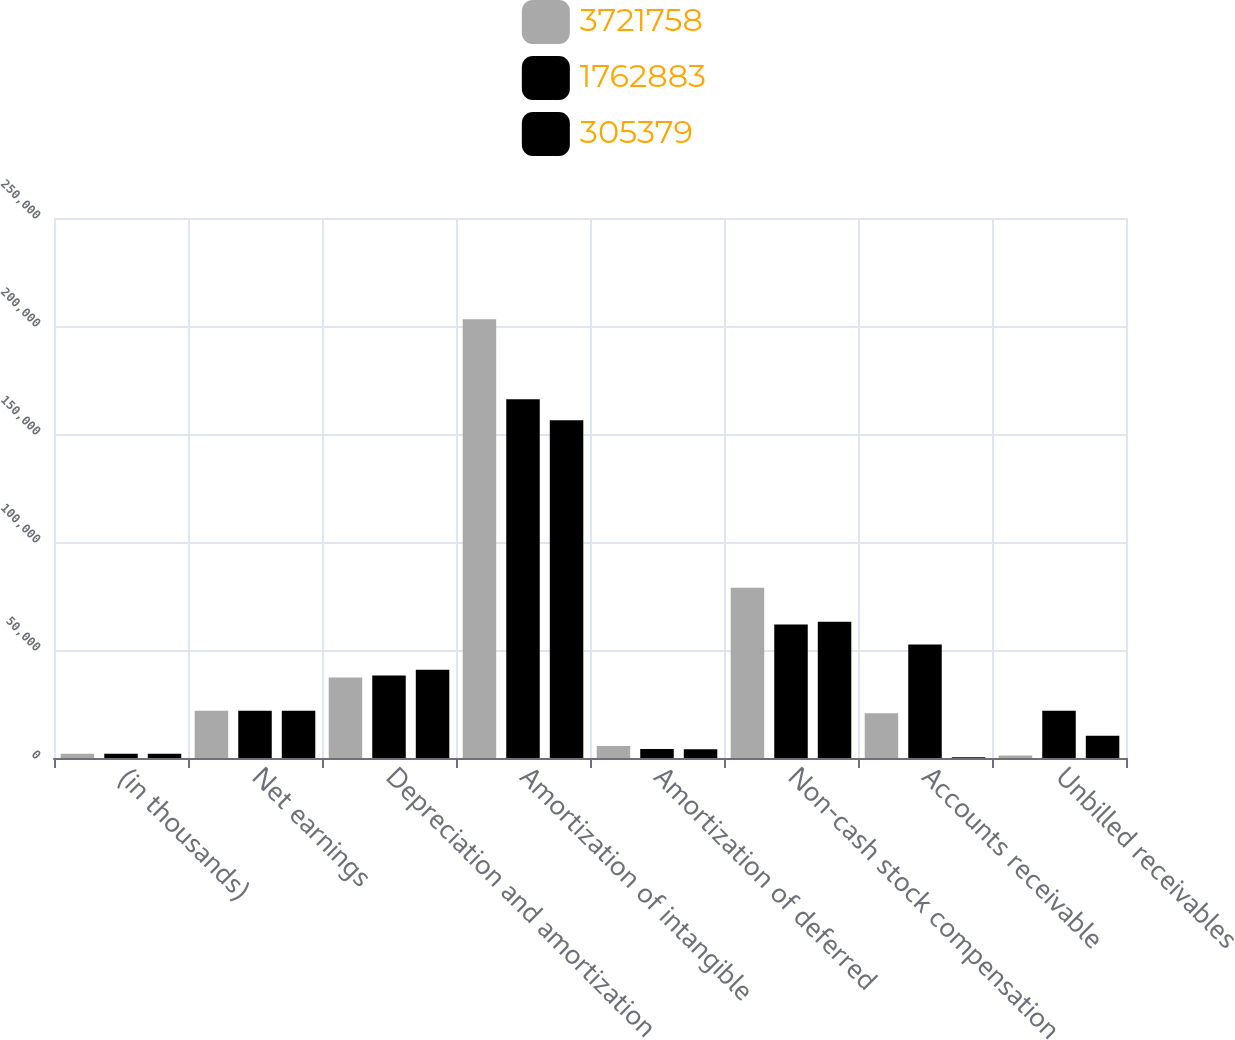Convert chart to OTSL. <chart><loc_0><loc_0><loc_500><loc_500><stacked_bar_chart><ecel><fcel>(in thousands)<fcel>Net earnings<fcel>Depreciation and amortization<fcel>Amortization of intangible<fcel>Amortization of deferred<fcel>Non-cash stock compensation<fcel>Accounts receivable<fcel>Unbilled receivables<nl><fcel>3.72176e+06<fcel>2016<fcel>21844<fcel>37299<fcel>203154<fcel>5612<fcel>78827<fcel>20734<fcel>1202<nl><fcel>1.76288e+06<fcel>2015<fcel>21844<fcel>38185<fcel>166076<fcel>4136<fcel>61766<fcel>52597<fcel>21844<nl><fcel>305379<fcel>2014<fcel>21844<fcel>40890<fcel>156394<fcel>4003<fcel>63027<fcel>404<fcel>10305<nl></chart> 